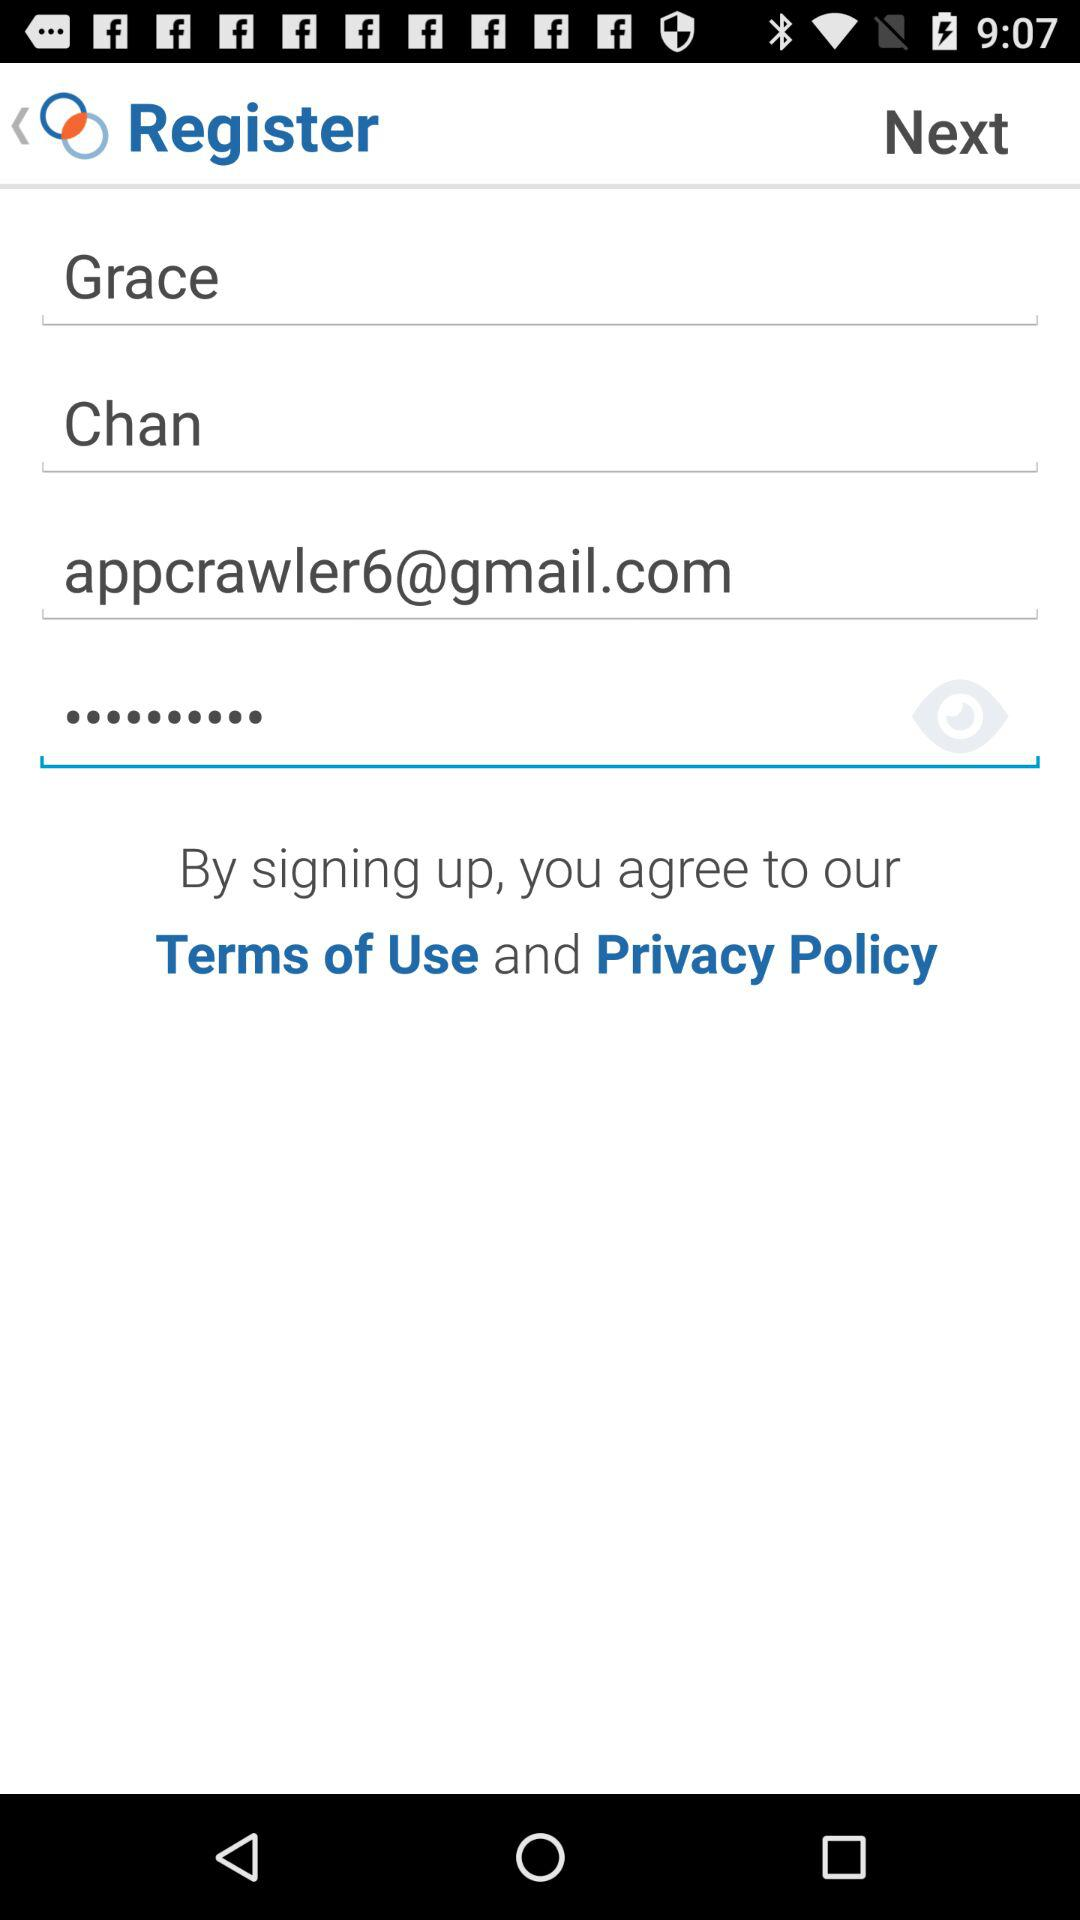What is the email address? The email address is appcrawler6@gmail.com. 